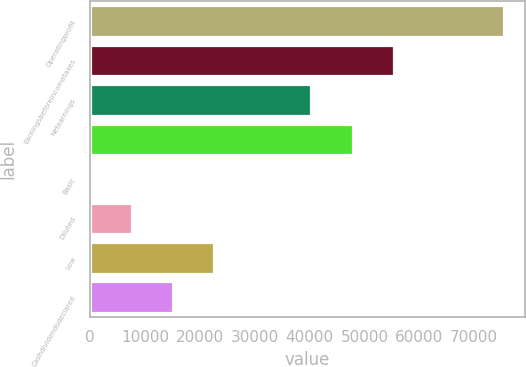Convert chart. <chart><loc_0><loc_0><loc_500><loc_500><bar_chart><fcel>Operatingprofit<fcel>Earningsbeforeincometaxes<fcel>Netearnings<fcel>Unnamed: 3<fcel>Basic<fcel>Diluted<fcel>Low<fcel>Cashdividendsdeclared<nl><fcel>75500<fcel>55381.9<fcel>40282<fcel>47832<fcel>0.33<fcel>7550.3<fcel>22650.2<fcel>15100.3<nl></chart> 